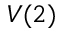Convert formula to latex. <formula><loc_0><loc_0><loc_500><loc_500>V ( 2 )</formula> 